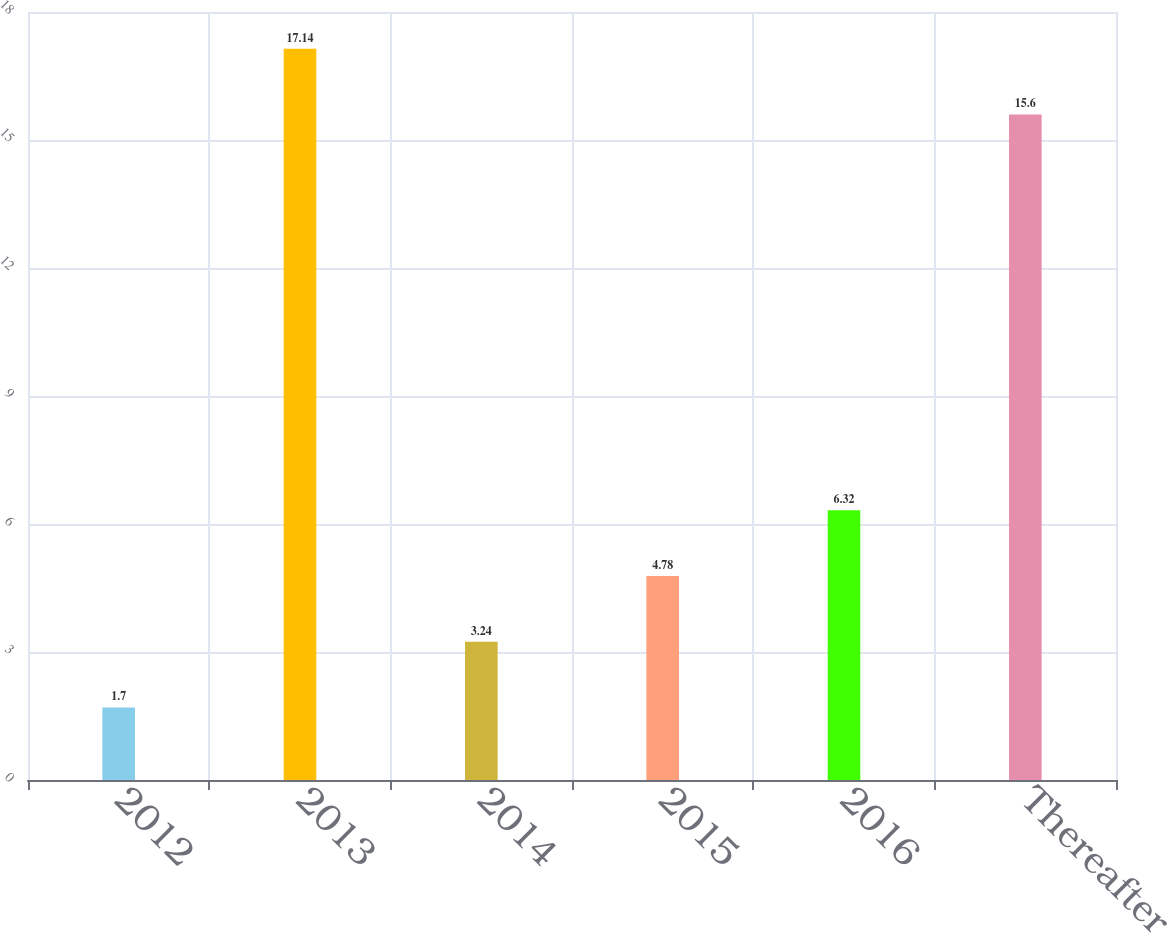Convert chart to OTSL. <chart><loc_0><loc_0><loc_500><loc_500><bar_chart><fcel>2012<fcel>2013<fcel>2014<fcel>2015<fcel>2016<fcel>Thereafter<nl><fcel>1.7<fcel>17.14<fcel>3.24<fcel>4.78<fcel>6.32<fcel>15.6<nl></chart> 